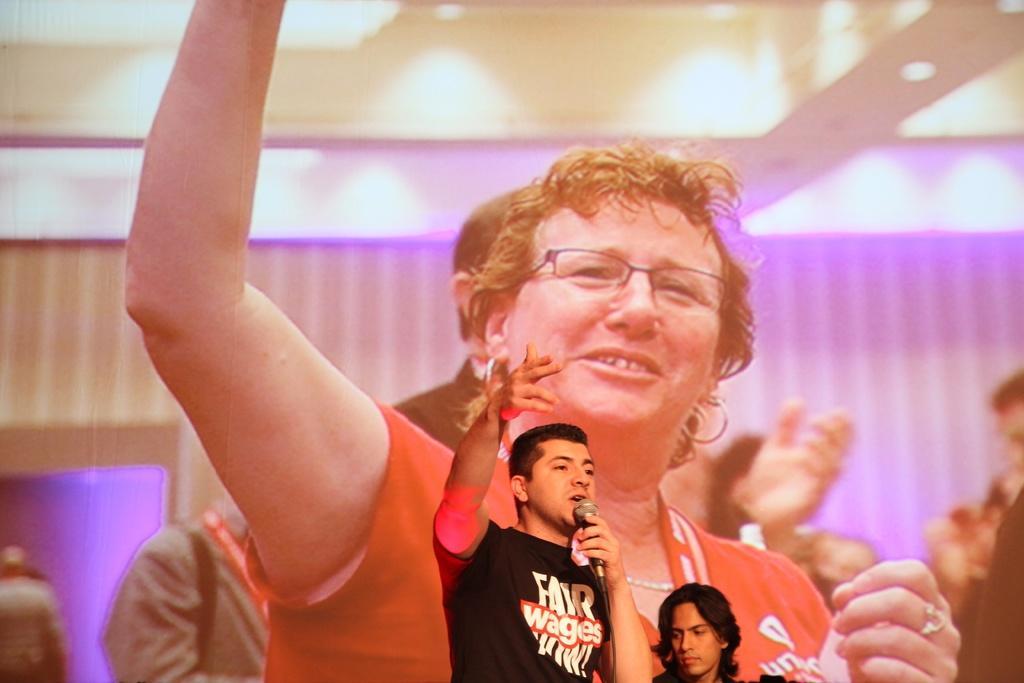Can you describe this image briefly? At the bottom of this image there is a man holding a mike in the hand and talking. Beside him there is another person. At the back of these people there is a screen on which I can see some more people. 